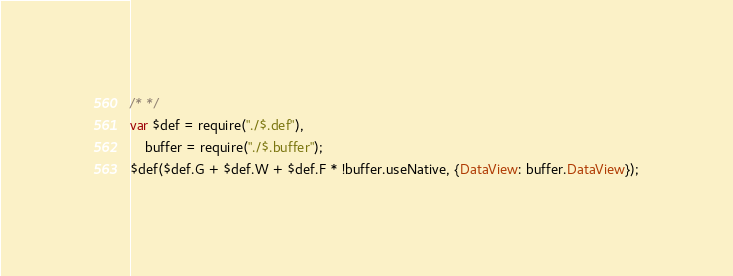Convert code to text. <code><loc_0><loc_0><loc_500><loc_500><_JavaScript_>/* */ 
var $def = require("./$.def"),
    buffer = require("./$.buffer");
$def($def.G + $def.W + $def.F * !buffer.useNative, {DataView: buffer.DataView});
</code> 